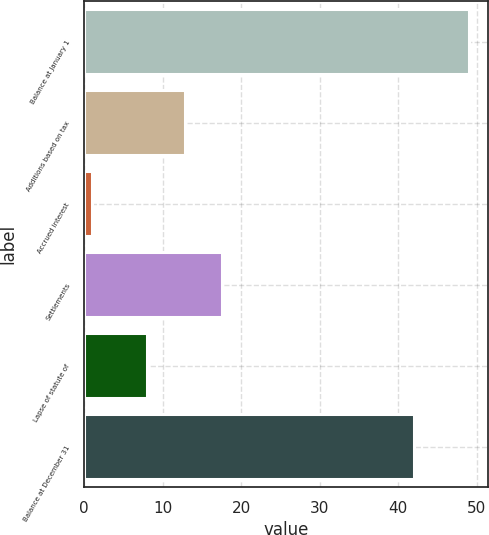<chart> <loc_0><loc_0><loc_500><loc_500><bar_chart><fcel>Balance at January 1<fcel>Additions based on tax<fcel>Accrued interest<fcel>Settlements<fcel>Lapse of statute of<fcel>Balance at December 31<nl><fcel>49<fcel>12.8<fcel>1<fcel>17.6<fcel>8<fcel>42<nl></chart> 